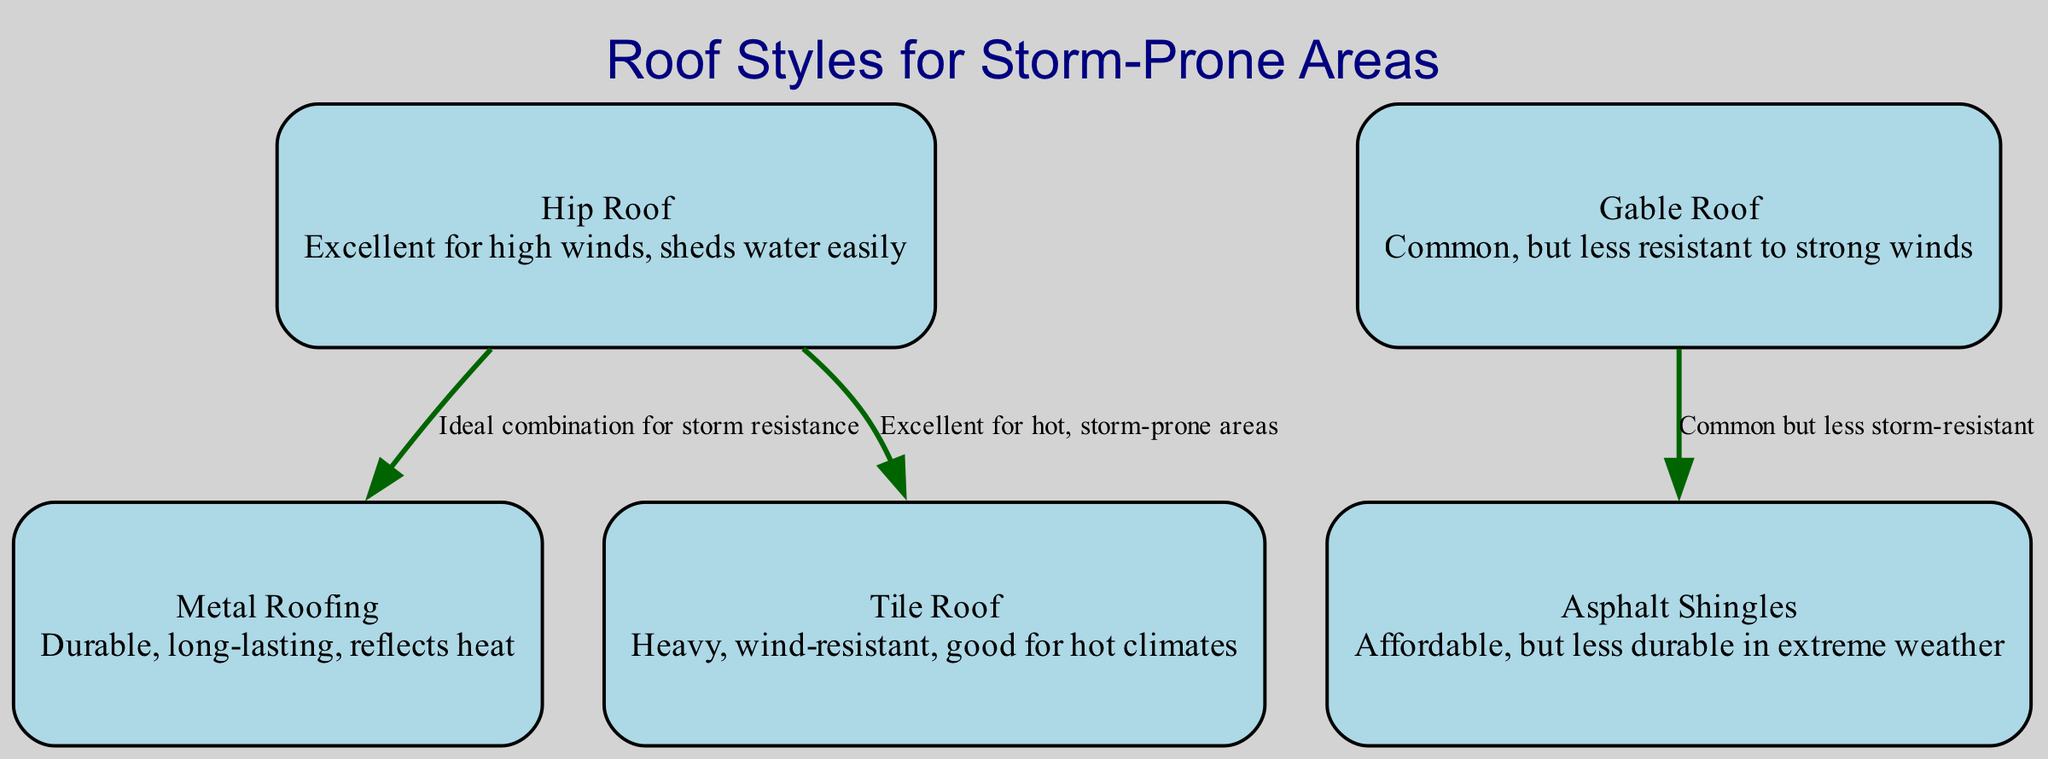What is the description of a Hip Roof? The diagram indicates that a Hip Roof is "Excellent for high winds, sheds water easily."
Answer: Excellent for high winds, sheds water easily How many different roof styles are shown in the diagram? By examining the nodes in the diagram, there are five unique roof styles: Hip Roof, Gable Roof, Metal Roofing, Asphalt Shingles, and Tile Roof.
Answer: Five What roof style is combined with Metal Roofing in the diagram? The edge from the Hip Roof node to the Metal Roofing node indicates that Hip Roof is ideal when combined with Metal Roofing for storm resistance.
Answer: Hip Roof Which roof type is noted as being "Common but less storm-resistant"? The edge connecting the Gable Roof node to the Asphalt Shingles node describes this relationship, identifying Gable Roof as the type that is common but less storm-resistant.
Answer: Gable Roof What is the relationship between Hip Roof and Tile Roof in terms of climate suitability? The diagram shows an edge indicating that Hip Roof is excellent for hot, storm-prone areas when associated with Tile Roof. This highlights their suitability together in such climates.
Answer: Excellent for hot, storm-prone areas How does the Asphalt Shingles roof type compare in durability during extreme weather? According to the description of Asphalt Shingles in the diagram, it is "Affordable, but less durable in extreme weather," highlighting its vulnerability compared to other types that provide better protection.
Answer: Less durable in extreme weather Which roof type is labeled as "Durable, long-lasting, reflects heat"? The description for Metal Roofing in the diagram provides this information directly, stating its durability and heat-reflective properties.
Answer: Metal Roofing What common trait do Hip Roof and Metal Roofing share? The diagram suggests a combination of these two roof types to be an "Ideal combination for storm resistance," indicating their shared strength in handling storms.
Answer: Ideal combination for storm resistance What is the primary contrast between Gable Roof and other more resistant roof types? Gable Roof is described as "Common, but less resistant to strong winds," highlighting its relative weakness compared to other roof types designed for better storm protection.
Answer: Less resistant to strong winds 